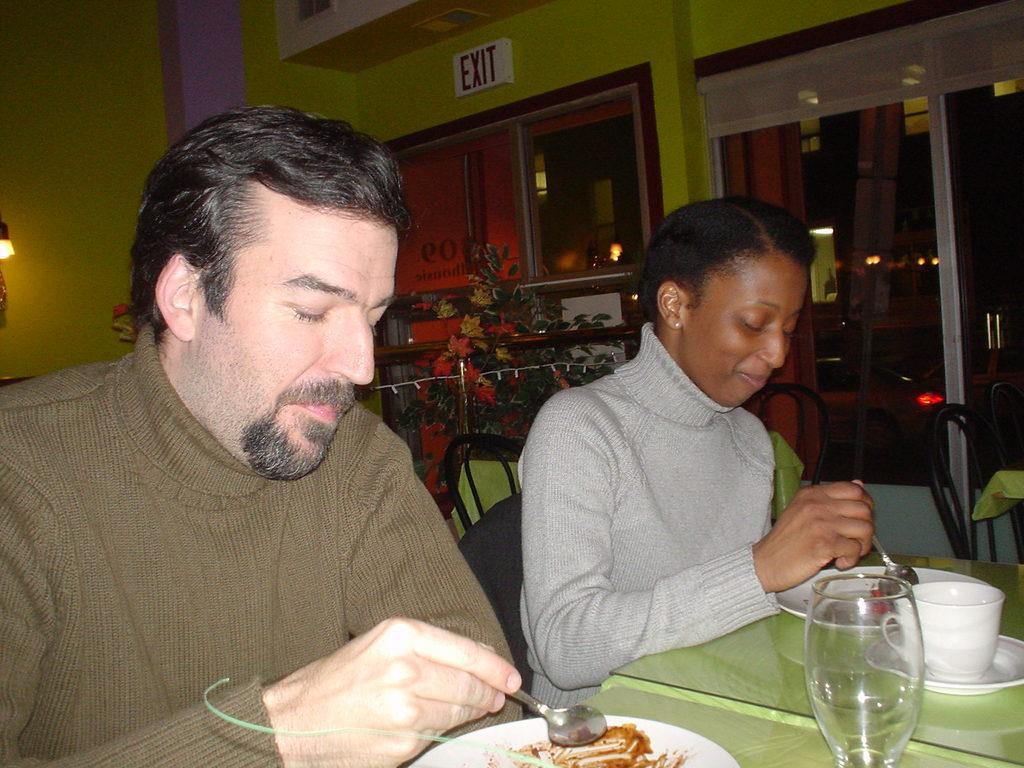Please provide a concise description of this image. The man on the left side of the picture wearing a brown T-shirt is sitting on the chair and he is holding a spoon in his hand. Beside him, we see the woman in grey T-shirt is also sitting on the chair and she is holding a spoon in her hand. She is smiling. They might be eating. In front of them, we see a table on which two plates, cup, saucer and glass are placed. Behind them, we see a flower vase, windows, lamp and a wall in green color. We even see an exit board is placed on the wall. On the right side, we see a door and a curtain. This picture might be clicked in the restaurant. 